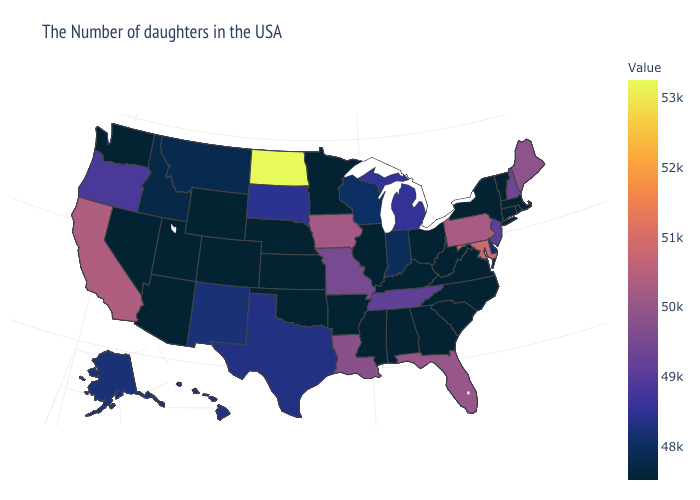Does North Carolina have the lowest value in the USA?
Answer briefly. Yes. Among the states that border Mississippi , does Louisiana have the highest value?
Answer briefly. Yes. Does Utah have the highest value in the USA?
Write a very short answer. No. Which states hav the highest value in the South?
Answer briefly. Maryland. Which states have the lowest value in the USA?
Quick response, please. Massachusetts, Rhode Island, Vermont, Connecticut, New York, Virginia, North Carolina, South Carolina, West Virginia, Ohio, Georgia, Kentucky, Alabama, Illinois, Mississippi, Arkansas, Minnesota, Kansas, Nebraska, Oklahoma, Wyoming, Colorado, Utah, Arizona, Nevada, Washington. Does Maryland have the highest value in the South?
Keep it brief. Yes. 